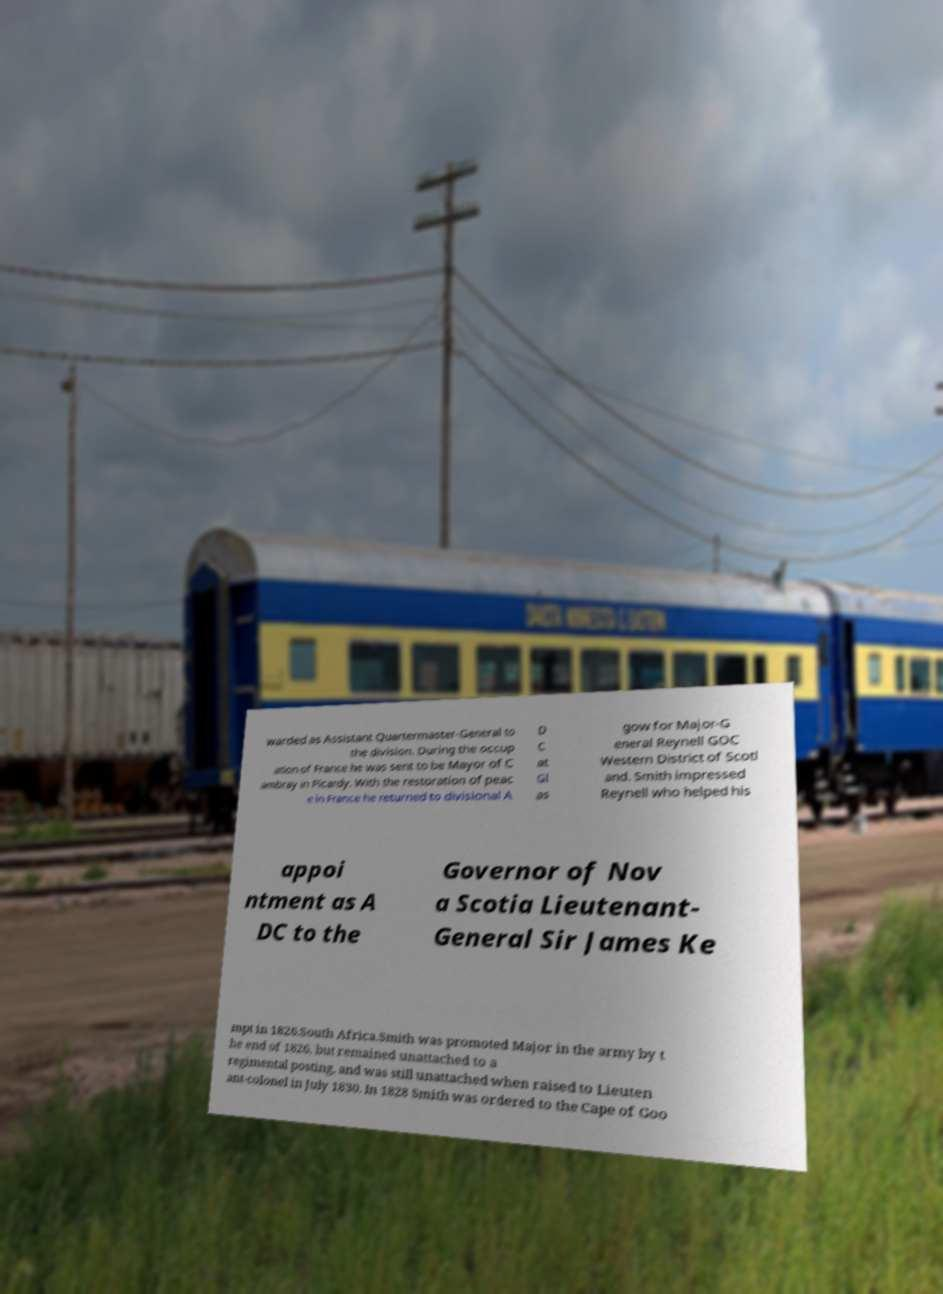Can you read and provide the text displayed in the image?This photo seems to have some interesting text. Can you extract and type it out for me? warded as Assistant Quartermaster-General to the division. During the occup ation of France he was sent to be Mayor of C ambray in Picardy. With the restoration of peac e in France he returned to divisional A D C at Gl as gow for Major-G eneral Reynell GOC Western District of Scotl and. Smith impressed Reynell who helped his appoi ntment as A DC to the Governor of Nov a Scotia Lieutenant- General Sir James Ke mpt in 1826.South Africa.Smith was promoted Major in the army by t he end of 1826, but remained unattached to a regimental posting, and was still unattached when raised to Lieuten ant-colonel in July 1830. In 1828 Smith was ordered to the Cape of Goo 